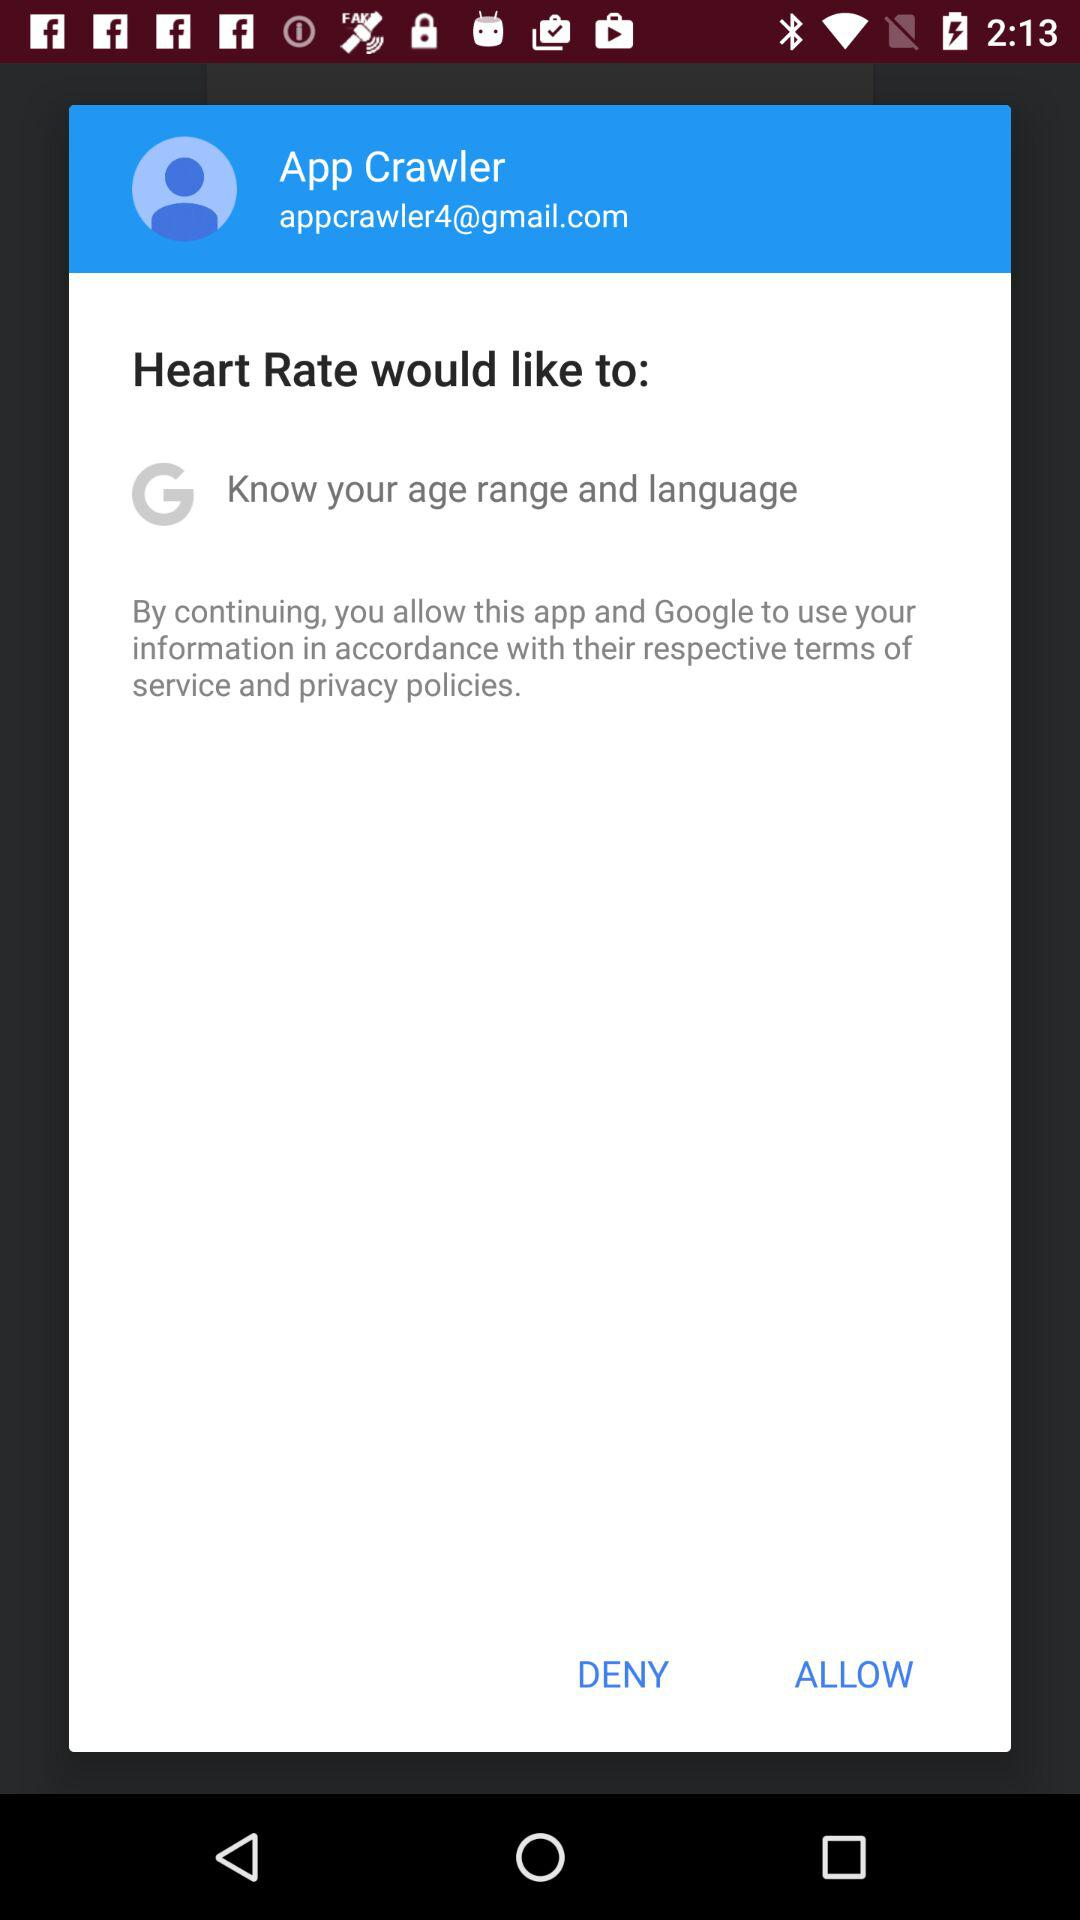What is the email address? The email address is appcrawler4@gmail.com. 